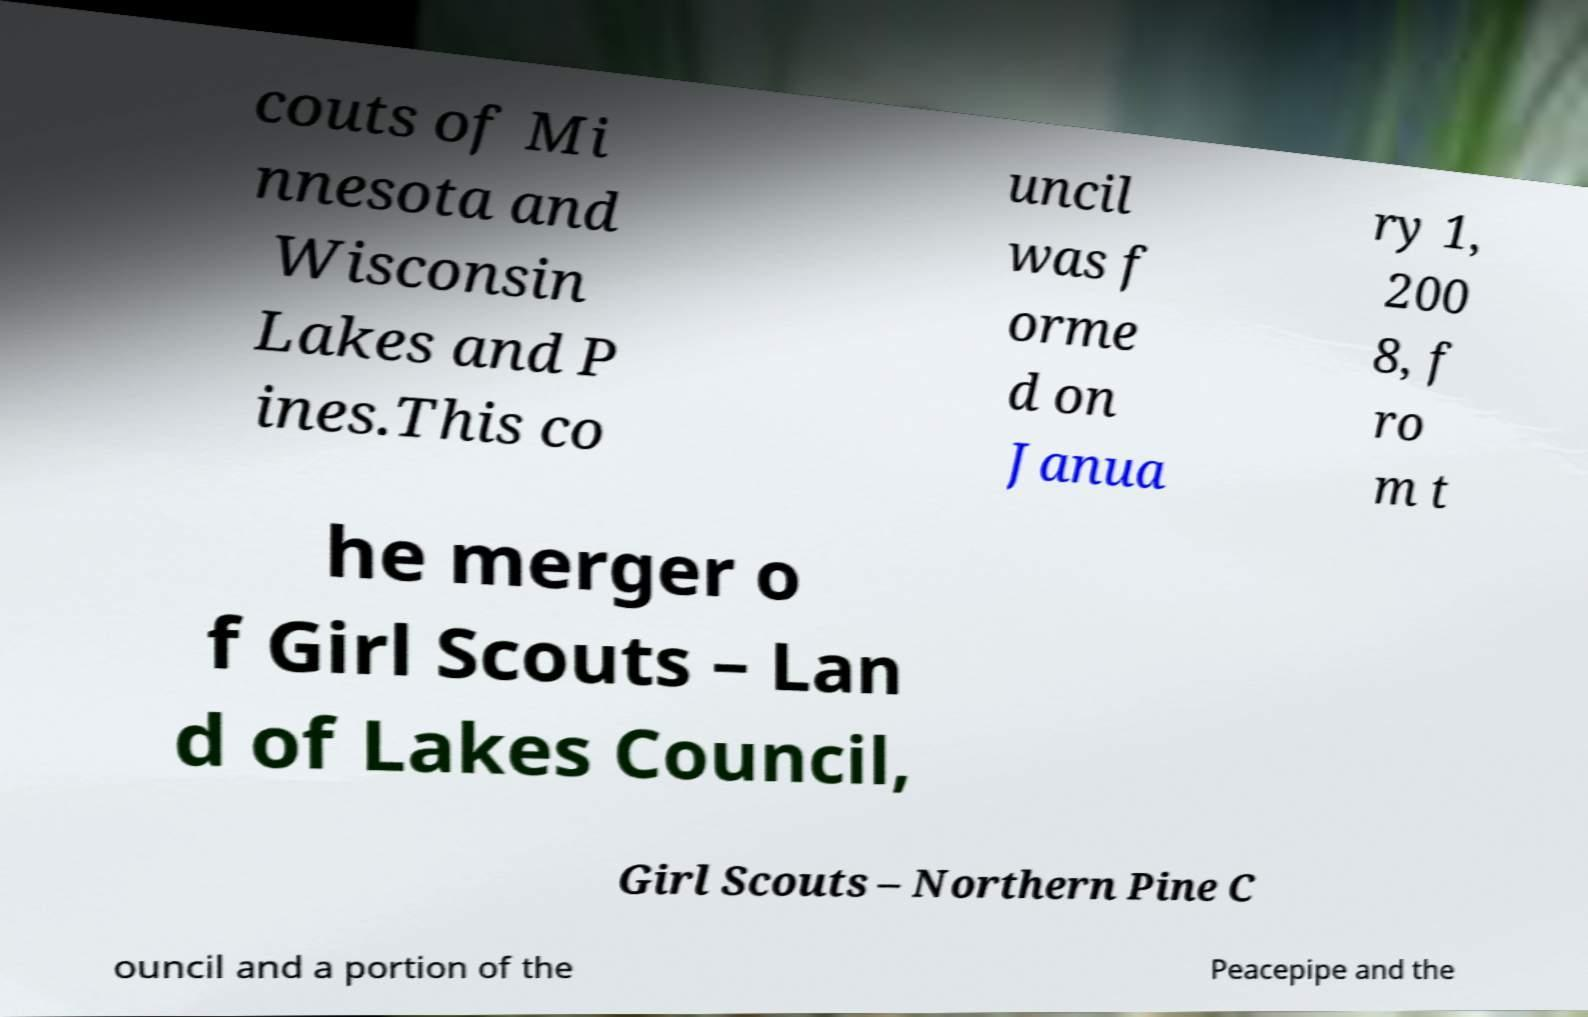Can you read and provide the text displayed in the image?This photo seems to have some interesting text. Can you extract and type it out for me? couts of Mi nnesota and Wisconsin Lakes and P ines.This co uncil was f orme d on Janua ry 1, 200 8, f ro m t he merger o f Girl Scouts – Lan d of Lakes Council, Girl Scouts – Northern Pine C ouncil and a portion of the Peacepipe and the 